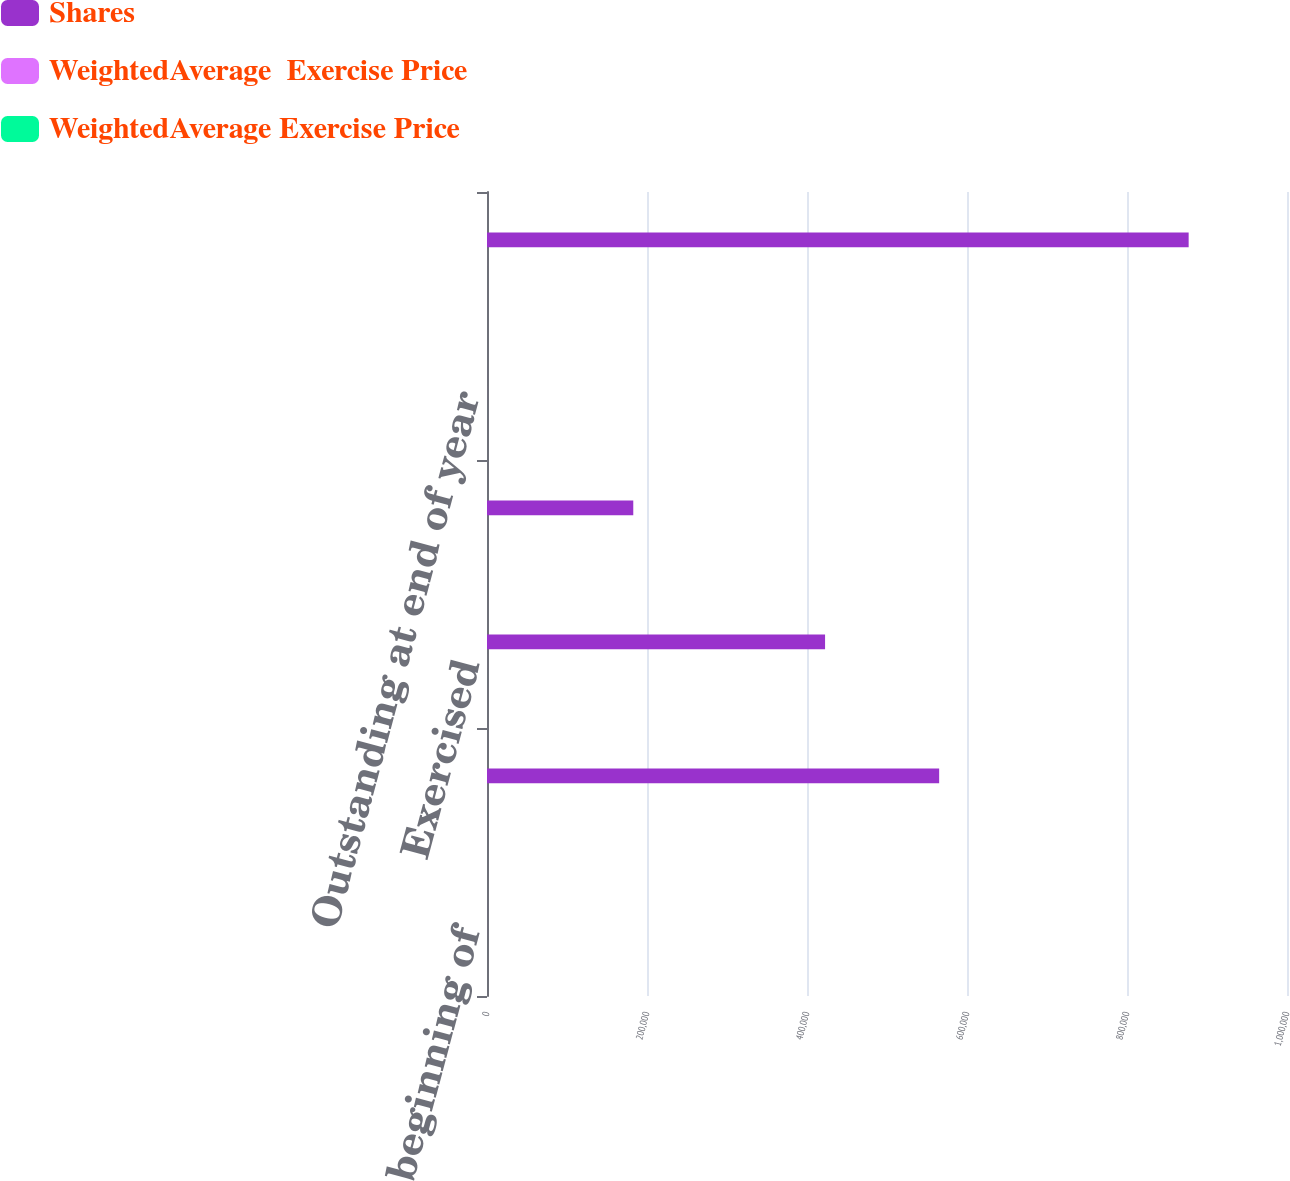Convert chart to OTSL. <chart><loc_0><loc_0><loc_500><loc_500><stacked_bar_chart><ecel><fcel>Outstanding at beginning of<fcel>Granted<fcel>Exercised<fcel>Canceled<fcel>Outstanding at end of year<fcel>Options exercisable at end of<nl><fcel>Shares<fcel>26.195<fcel>565200<fcel>422586<fcel>182837<fcel>26.195<fcel>877068<nl><fcel>WeightedAverage  Exercise Price<fcel>25.37<fcel>48.62<fcel>20.26<fcel>29.85<fcel>31.04<fcel>23.11<nl><fcel>WeightedAverage Exercise Price<fcel>19.34<fcel>27.02<fcel>17.2<fcel>21.92<fcel>21.61<fcel>17.64<nl></chart> 